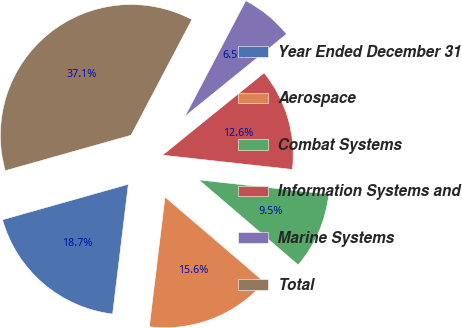Convert chart to OTSL. <chart><loc_0><loc_0><loc_500><loc_500><pie_chart><fcel>Year Ended December 31<fcel>Aerospace<fcel>Combat Systems<fcel>Information Systems and<fcel>Marine Systems<fcel>Total<nl><fcel>18.71%<fcel>15.65%<fcel>9.52%<fcel>12.58%<fcel>6.46%<fcel>37.08%<nl></chart> 